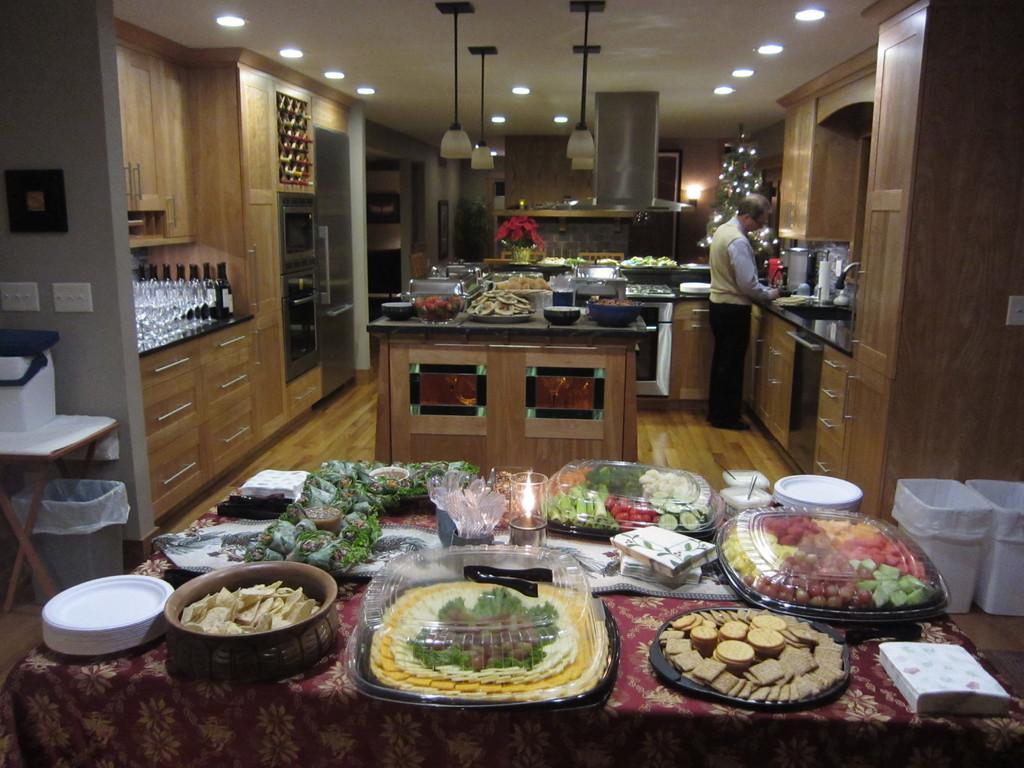How would you summarize this image in a sentence or two? In the image we can see there are food items kept on the table and there is a man standing in the kitchen. There are wine glasses and wine bottles kept on the table. There are lights on the top. 